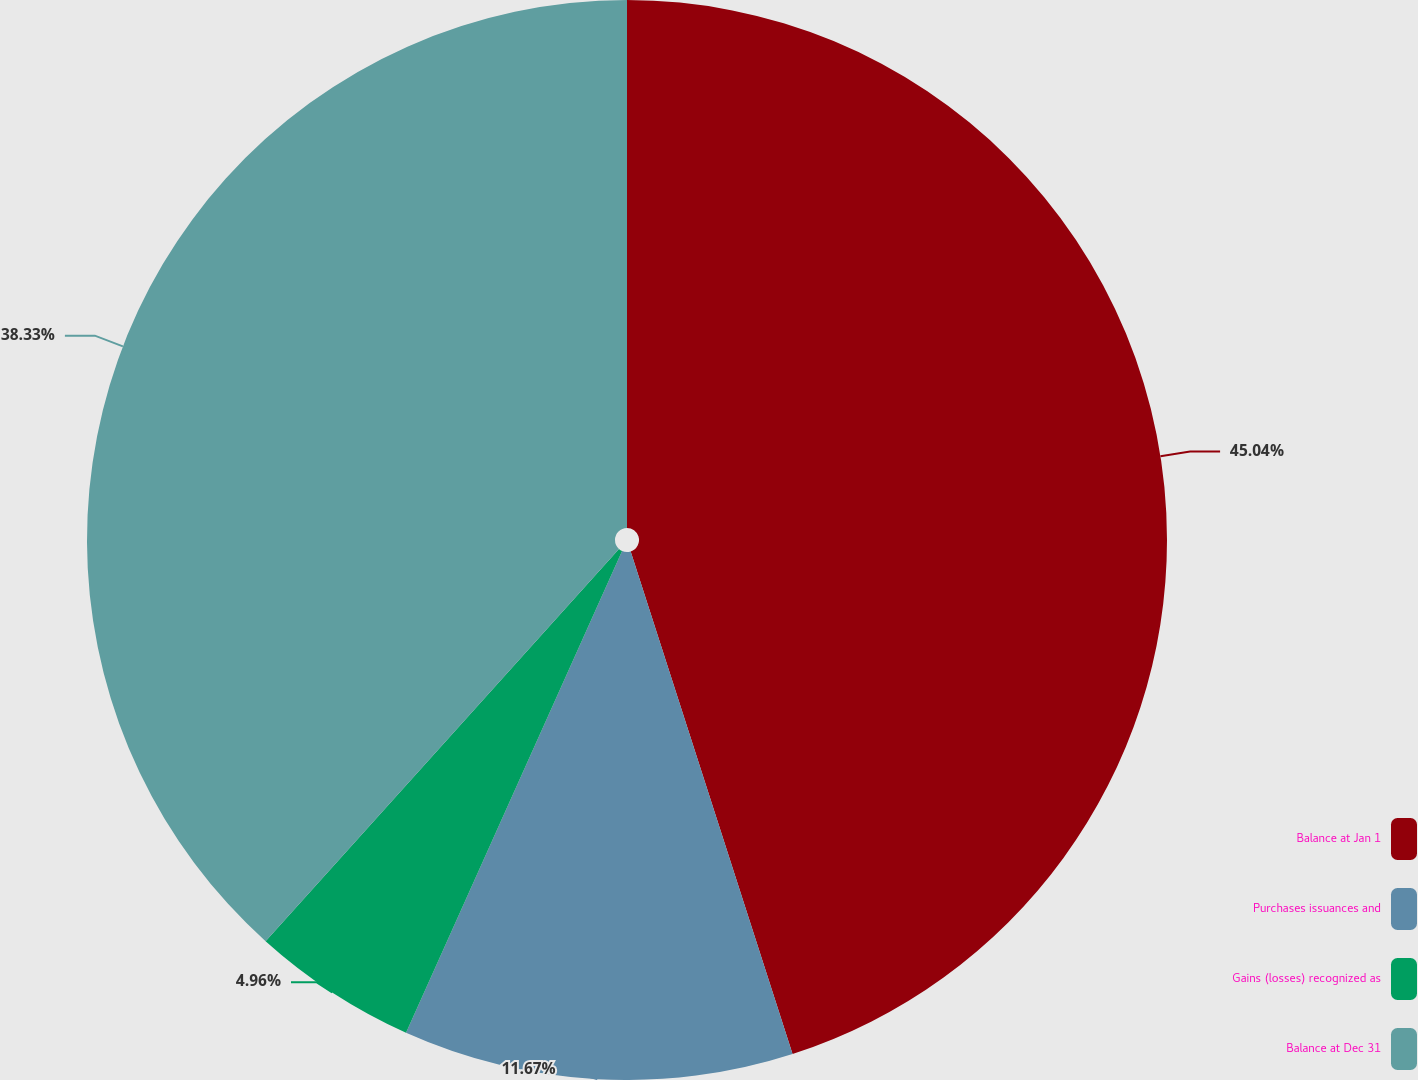Convert chart. <chart><loc_0><loc_0><loc_500><loc_500><pie_chart><fcel>Balance at Jan 1<fcel>Purchases issuances and<fcel>Gains (losses) recognized as<fcel>Balance at Dec 31<nl><fcel>45.04%<fcel>11.67%<fcel>4.96%<fcel>38.33%<nl></chart> 